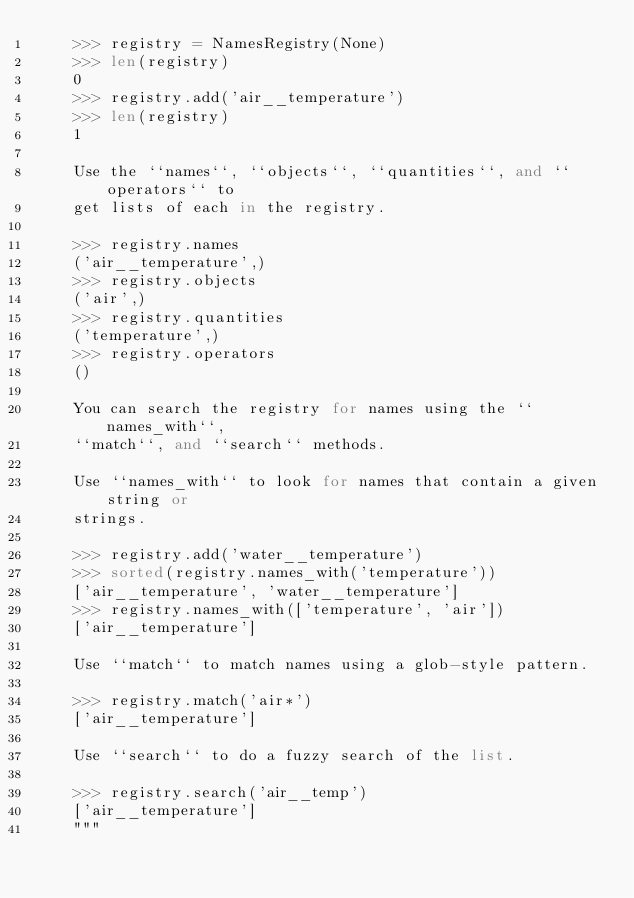<code> <loc_0><loc_0><loc_500><loc_500><_Python_>    >>> registry = NamesRegistry(None)
    >>> len(registry)
    0
    >>> registry.add('air__temperature')
    >>> len(registry)
    1

    Use the ``names``, ``objects``, ``quantities``, and ``operators`` to
    get lists of each in the registry.

    >>> registry.names
    ('air__temperature',)
    >>> registry.objects
    ('air',)
    >>> registry.quantities
    ('temperature',)
    >>> registry.operators
    ()

    You can search the registry for names using the ``names_with``,
    ``match``, and ``search`` methods.

    Use ``names_with`` to look for names that contain a given string or
    strings.

    >>> registry.add('water__temperature')
    >>> sorted(registry.names_with('temperature'))
    ['air__temperature', 'water__temperature']
    >>> registry.names_with(['temperature', 'air'])
    ['air__temperature']

    Use ``match`` to match names using a glob-style pattern.

    >>> registry.match('air*')
    ['air__temperature']

    Use ``search`` to do a fuzzy search of the list.

    >>> registry.search('air__temp')
    ['air__temperature']
    """
</code> 